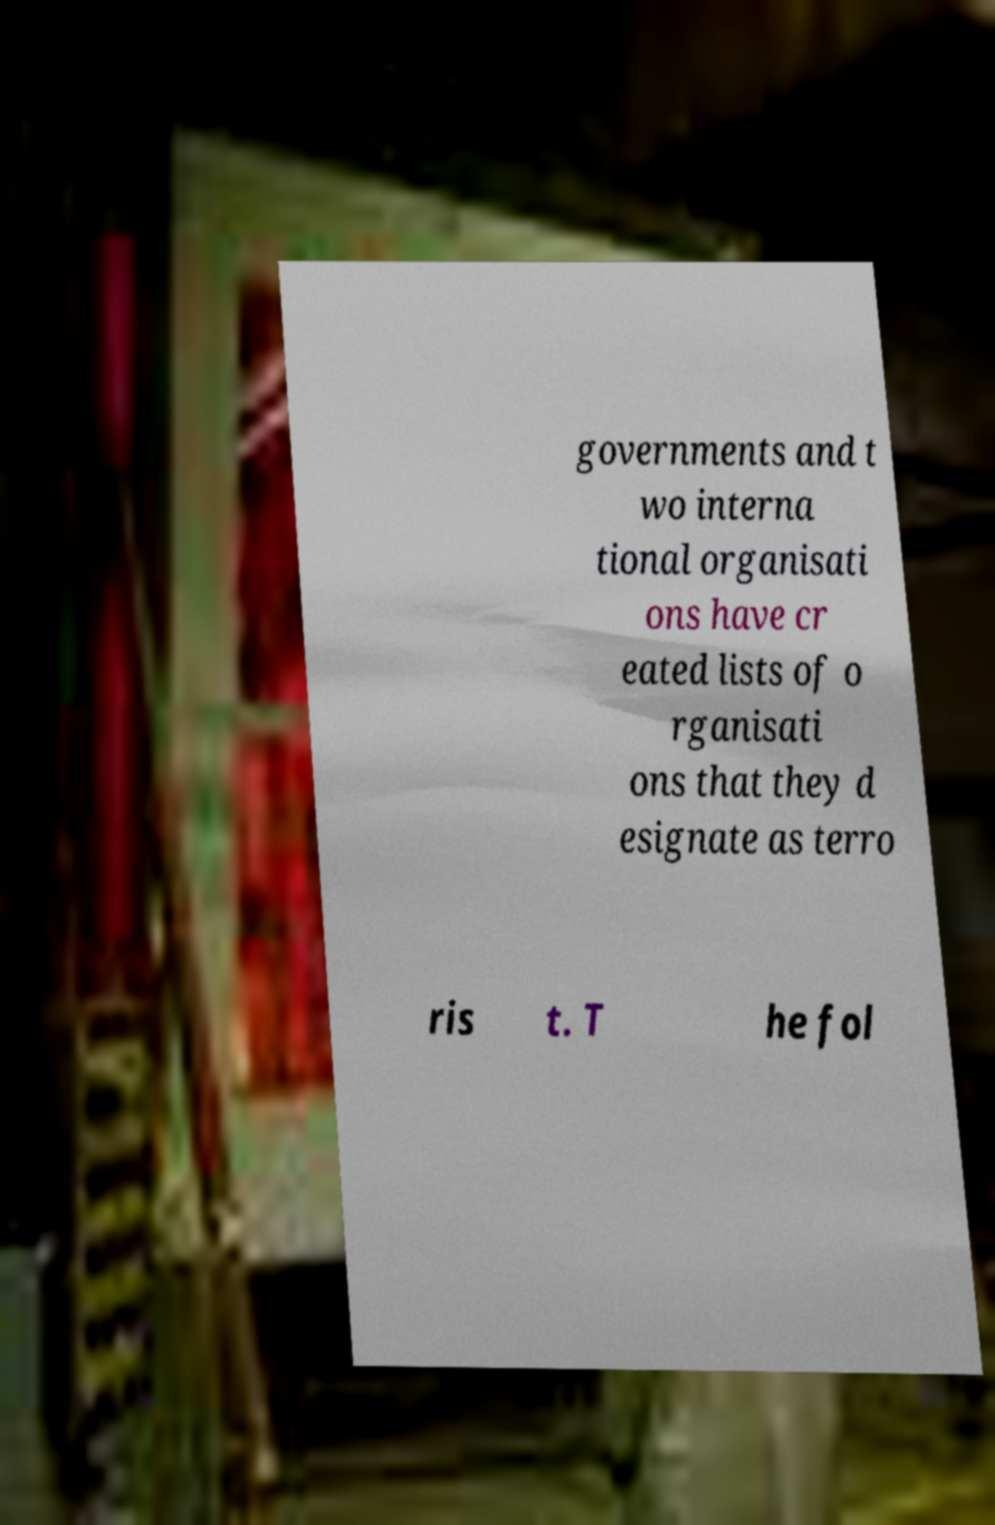Can you accurately transcribe the text from the provided image for me? governments and t wo interna tional organisati ons have cr eated lists of o rganisati ons that they d esignate as terro ris t. T he fol 